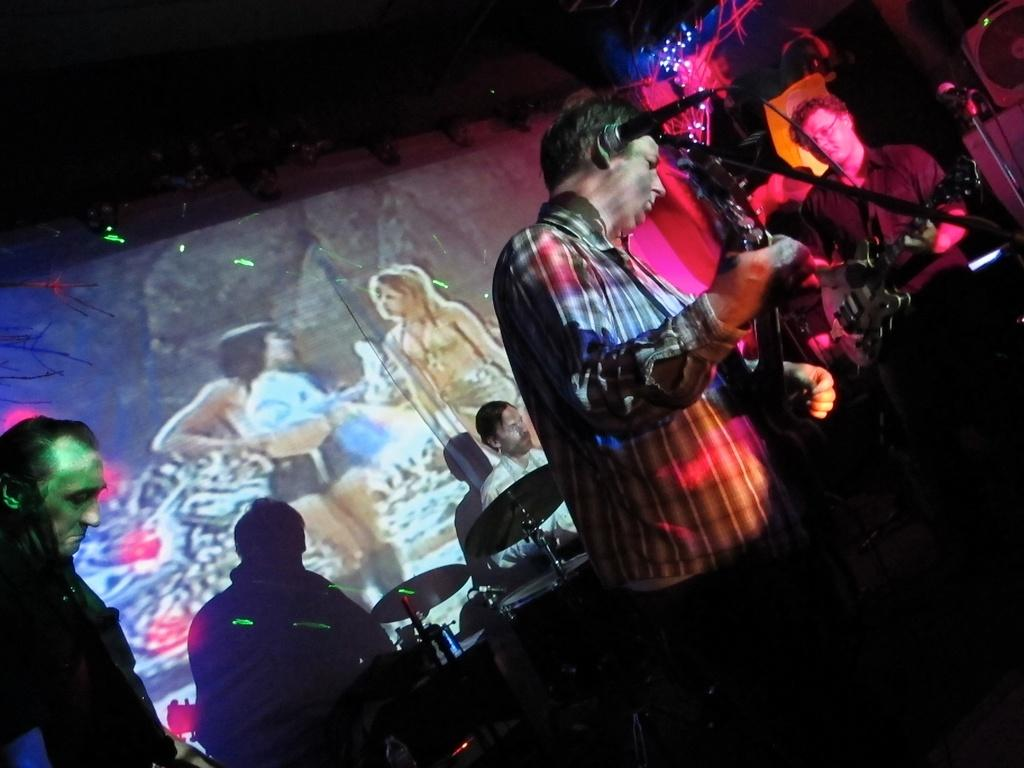What is the man in the image holding? The man is holding a guitar in the image. Are there any other musicians in the image? Yes, there are other men holding musical instruments in the image. What are the two girls in the image doing? The girls are painting on a wall in the image. What type of birds can be seen flying near the coast in the image? There are no birds or coast visible in the image; it features a man holding a guitar, other musicians, and two girls painting on a wall. 